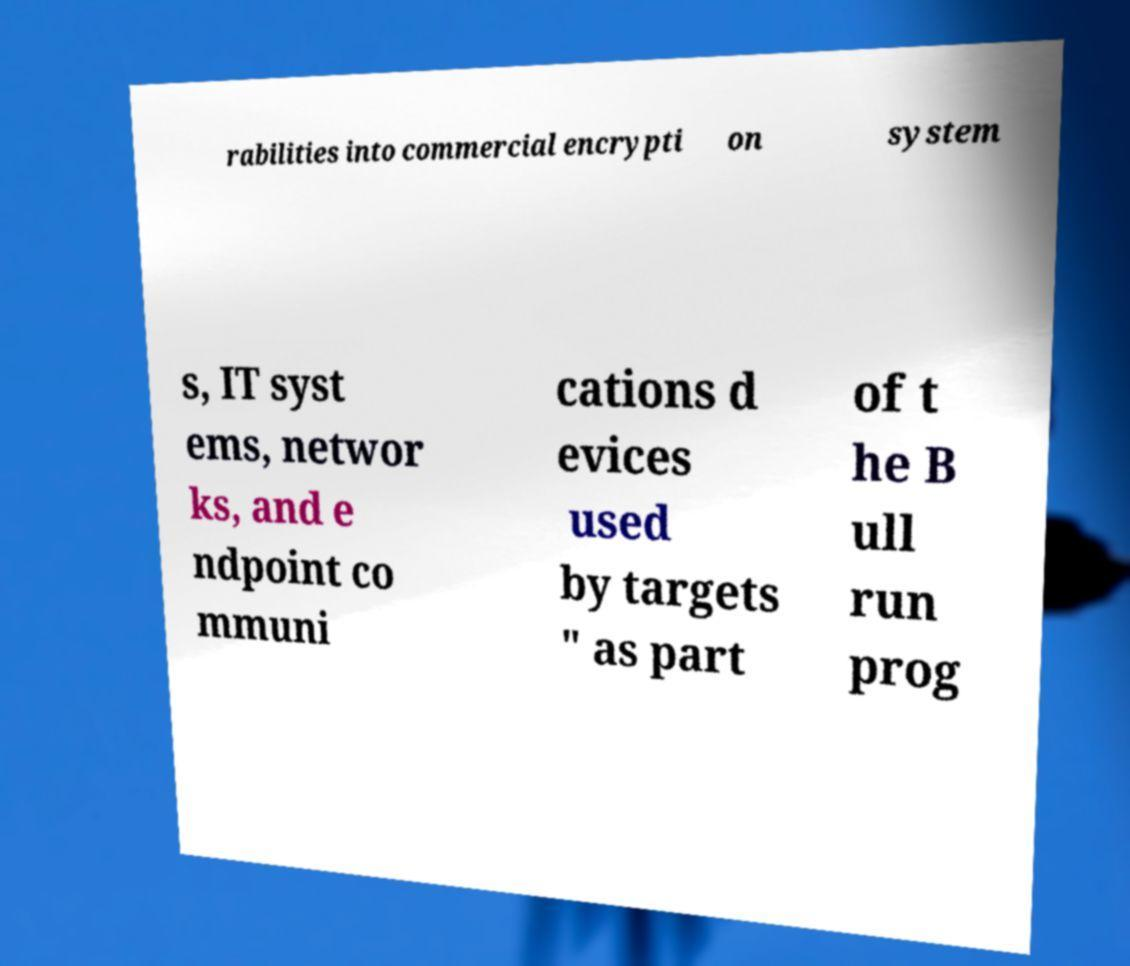Can you read and provide the text displayed in the image?This photo seems to have some interesting text. Can you extract and type it out for me? rabilities into commercial encrypti on system s, IT syst ems, networ ks, and e ndpoint co mmuni cations d evices used by targets " as part of t he B ull run prog 